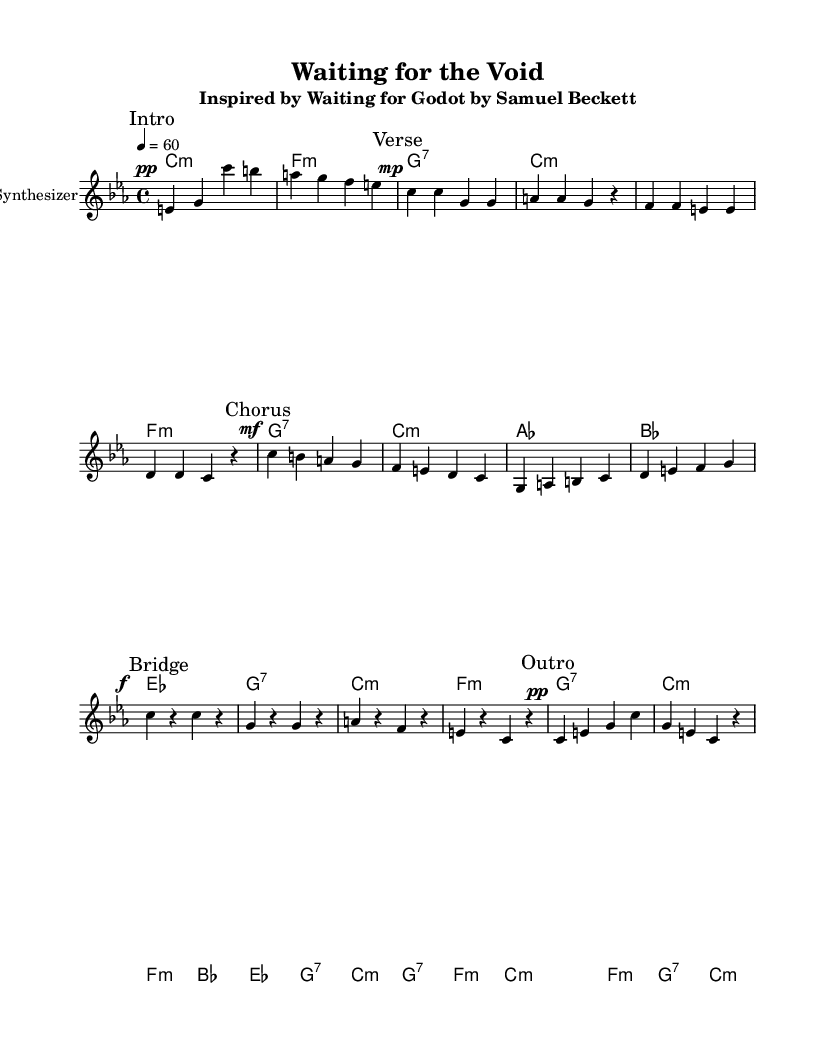What is the key signature of this music? The key signature is C minor, which includes three flats (B-flat, E-flat, and A-flat).
Answer: C minor What is the time signature of this music? The time signature is 4/4, indicating there are four beats per measure, with each quarter note receiving one beat.
Answer: 4/4 What is the tempo marking of the piece? The tempo marking is given as a quarter note equals sixty beats per minute, indicating a slow tempo.
Answer: 60 How many sections does the music have? The music has five distinct sections as marked: Intro, Verse, Chorus, Bridge, and Outro.
Answer: Five What is the dynamic marking for the chorus? The dynamic marking for the chorus is mezzo-forte, indicating a moderate loudness.
Answer: mezzo-forte In which section is the melody marked "Bridge" found? The melody marked "Bridge" is found after the "Chorus" section, indicating a transition in the musical narrative.
Answer: Bridge What type of chords are used in the harmonies for the intro? The harmonies in the intro consist of minor and seventh chords, specifically C minor, F minor, G seventh, and C minor.
Answer: Minor and seventh chords 